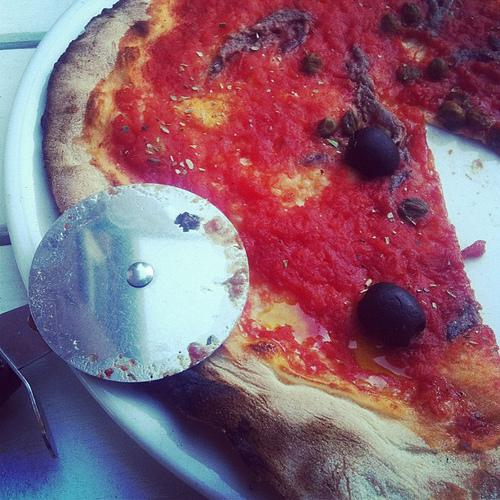Question: where was this picture taken?
Choices:
A. Under the stars.
B. In the living room.
C. In the basement.
D. Over a table.
Answer with the letter. Answer: D Question: what type of food is this?
Choices:
A. Quesadilla.
B. Calzone.
C. Pasta.
D. Pizza.
Answer with the letter. Answer: D Question: what is on the tomato sauce?
Choices:
A. Olives.
B. Cheese.
C. Pepperoni.
D. Peppers.
Answer with the letter. Answer: A Question: what is the pizza on?
Choices:
A. Plate.
B. Dining table.
C. Baking tray.
D. Oven rack.
Answer with the letter. Answer: A 